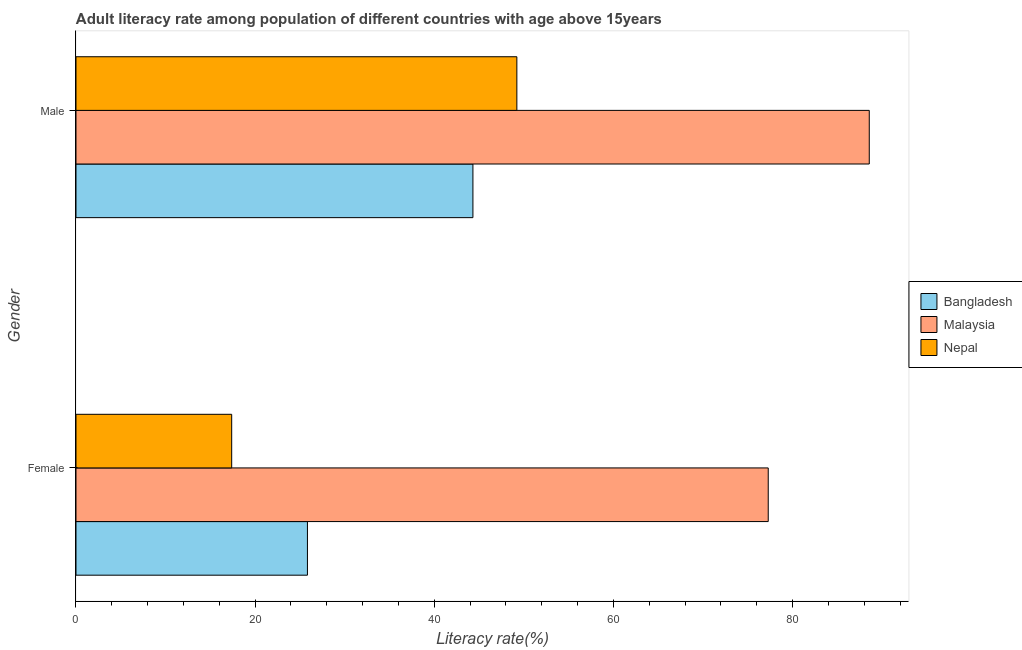How many different coloured bars are there?
Keep it short and to the point. 3. Are the number of bars per tick equal to the number of legend labels?
Offer a very short reply. Yes. How many bars are there on the 1st tick from the bottom?
Your response must be concise. 3. What is the male adult literacy rate in Bangladesh?
Your answer should be compact. 44.31. Across all countries, what is the maximum male adult literacy rate?
Your response must be concise. 88.56. Across all countries, what is the minimum male adult literacy rate?
Your response must be concise. 44.31. In which country was the male adult literacy rate maximum?
Offer a terse response. Malaysia. In which country was the female adult literacy rate minimum?
Offer a very short reply. Nepal. What is the total male adult literacy rate in the graph?
Your answer should be compact. 182.1. What is the difference between the female adult literacy rate in Bangladesh and that in Malaysia?
Provide a succinct answer. -51.44. What is the difference between the male adult literacy rate in Nepal and the female adult literacy rate in Malaysia?
Provide a short and direct response. -28.06. What is the average female adult literacy rate per country?
Make the answer very short. 40.17. What is the difference between the female adult literacy rate and male adult literacy rate in Nepal?
Keep it short and to the point. -31.84. In how many countries, is the female adult literacy rate greater than 48 %?
Offer a terse response. 1. What is the ratio of the male adult literacy rate in Nepal to that in Bangladesh?
Provide a succinct answer. 1.11. What does the 3rd bar from the top in Female represents?
Give a very brief answer. Bangladesh. What does the 2nd bar from the bottom in Male represents?
Give a very brief answer. Malaysia. How many bars are there?
Your answer should be very brief. 6. Are all the bars in the graph horizontal?
Provide a succinct answer. Yes. How many countries are there in the graph?
Give a very brief answer. 3. What is the difference between two consecutive major ticks on the X-axis?
Your response must be concise. 20. Are the values on the major ticks of X-axis written in scientific E-notation?
Offer a very short reply. No. Does the graph contain grids?
Your response must be concise. No. How many legend labels are there?
Offer a very short reply. 3. What is the title of the graph?
Make the answer very short. Adult literacy rate among population of different countries with age above 15years. What is the label or title of the X-axis?
Keep it short and to the point. Literacy rate(%). What is the Literacy rate(%) of Bangladesh in Female?
Offer a very short reply. 25.84. What is the Literacy rate(%) of Malaysia in Female?
Ensure brevity in your answer.  77.28. What is the Literacy rate(%) in Nepal in Female?
Your response must be concise. 17.38. What is the Literacy rate(%) of Bangladesh in Male?
Make the answer very short. 44.31. What is the Literacy rate(%) in Malaysia in Male?
Provide a short and direct response. 88.56. What is the Literacy rate(%) in Nepal in Male?
Make the answer very short. 49.22. Across all Gender, what is the maximum Literacy rate(%) in Bangladesh?
Make the answer very short. 44.31. Across all Gender, what is the maximum Literacy rate(%) in Malaysia?
Your answer should be compact. 88.56. Across all Gender, what is the maximum Literacy rate(%) of Nepal?
Your response must be concise. 49.22. Across all Gender, what is the minimum Literacy rate(%) of Bangladesh?
Your answer should be compact. 25.84. Across all Gender, what is the minimum Literacy rate(%) of Malaysia?
Offer a terse response. 77.28. Across all Gender, what is the minimum Literacy rate(%) of Nepal?
Provide a succinct answer. 17.38. What is the total Literacy rate(%) in Bangladesh in the graph?
Your answer should be compact. 70.15. What is the total Literacy rate(%) of Malaysia in the graph?
Provide a succinct answer. 165.85. What is the total Literacy rate(%) in Nepal in the graph?
Give a very brief answer. 66.6. What is the difference between the Literacy rate(%) of Bangladesh in Female and that in Male?
Offer a terse response. -18.48. What is the difference between the Literacy rate(%) in Malaysia in Female and that in Male?
Ensure brevity in your answer.  -11.28. What is the difference between the Literacy rate(%) of Nepal in Female and that in Male?
Offer a very short reply. -31.84. What is the difference between the Literacy rate(%) in Bangladesh in Female and the Literacy rate(%) in Malaysia in Male?
Ensure brevity in your answer.  -62.72. What is the difference between the Literacy rate(%) in Bangladesh in Female and the Literacy rate(%) in Nepal in Male?
Your answer should be very brief. -23.38. What is the difference between the Literacy rate(%) in Malaysia in Female and the Literacy rate(%) in Nepal in Male?
Keep it short and to the point. 28.06. What is the average Literacy rate(%) in Bangladesh per Gender?
Your answer should be very brief. 35.08. What is the average Literacy rate(%) in Malaysia per Gender?
Your answer should be very brief. 82.92. What is the average Literacy rate(%) of Nepal per Gender?
Your answer should be very brief. 33.3. What is the difference between the Literacy rate(%) in Bangladesh and Literacy rate(%) in Malaysia in Female?
Your response must be concise. -51.44. What is the difference between the Literacy rate(%) in Bangladesh and Literacy rate(%) in Nepal in Female?
Your answer should be very brief. 8.46. What is the difference between the Literacy rate(%) of Malaysia and Literacy rate(%) of Nepal in Female?
Give a very brief answer. 59.9. What is the difference between the Literacy rate(%) in Bangladesh and Literacy rate(%) in Malaysia in Male?
Provide a short and direct response. -44.25. What is the difference between the Literacy rate(%) in Bangladesh and Literacy rate(%) in Nepal in Male?
Make the answer very short. -4.91. What is the difference between the Literacy rate(%) in Malaysia and Literacy rate(%) in Nepal in Male?
Give a very brief answer. 39.34. What is the ratio of the Literacy rate(%) in Bangladesh in Female to that in Male?
Your answer should be very brief. 0.58. What is the ratio of the Literacy rate(%) in Malaysia in Female to that in Male?
Give a very brief answer. 0.87. What is the ratio of the Literacy rate(%) of Nepal in Female to that in Male?
Give a very brief answer. 0.35. What is the difference between the highest and the second highest Literacy rate(%) in Bangladesh?
Offer a terse response. 18.48. What is the difference between the highest and the second highest Literacy rate(%) in Malaysia?
Provide a succinct answer. 11.28. What is the difference between the highest and the second highest Literacy rate(%) of Nepal?
Offer a very short reply. 31.84. What is the difference between the highest and the lowest Literacy rate(%) in Bangladesh?
Your answer should be very brief. 18.48. What is the difference between the highest and the lowest Literacy rate(%) in Malaysia?
Make the answer very short. 11.28. What is the difference between the highest and the lowest Literacy rate(%) in Nepal?
Provide a succinct answer. 31.84. 